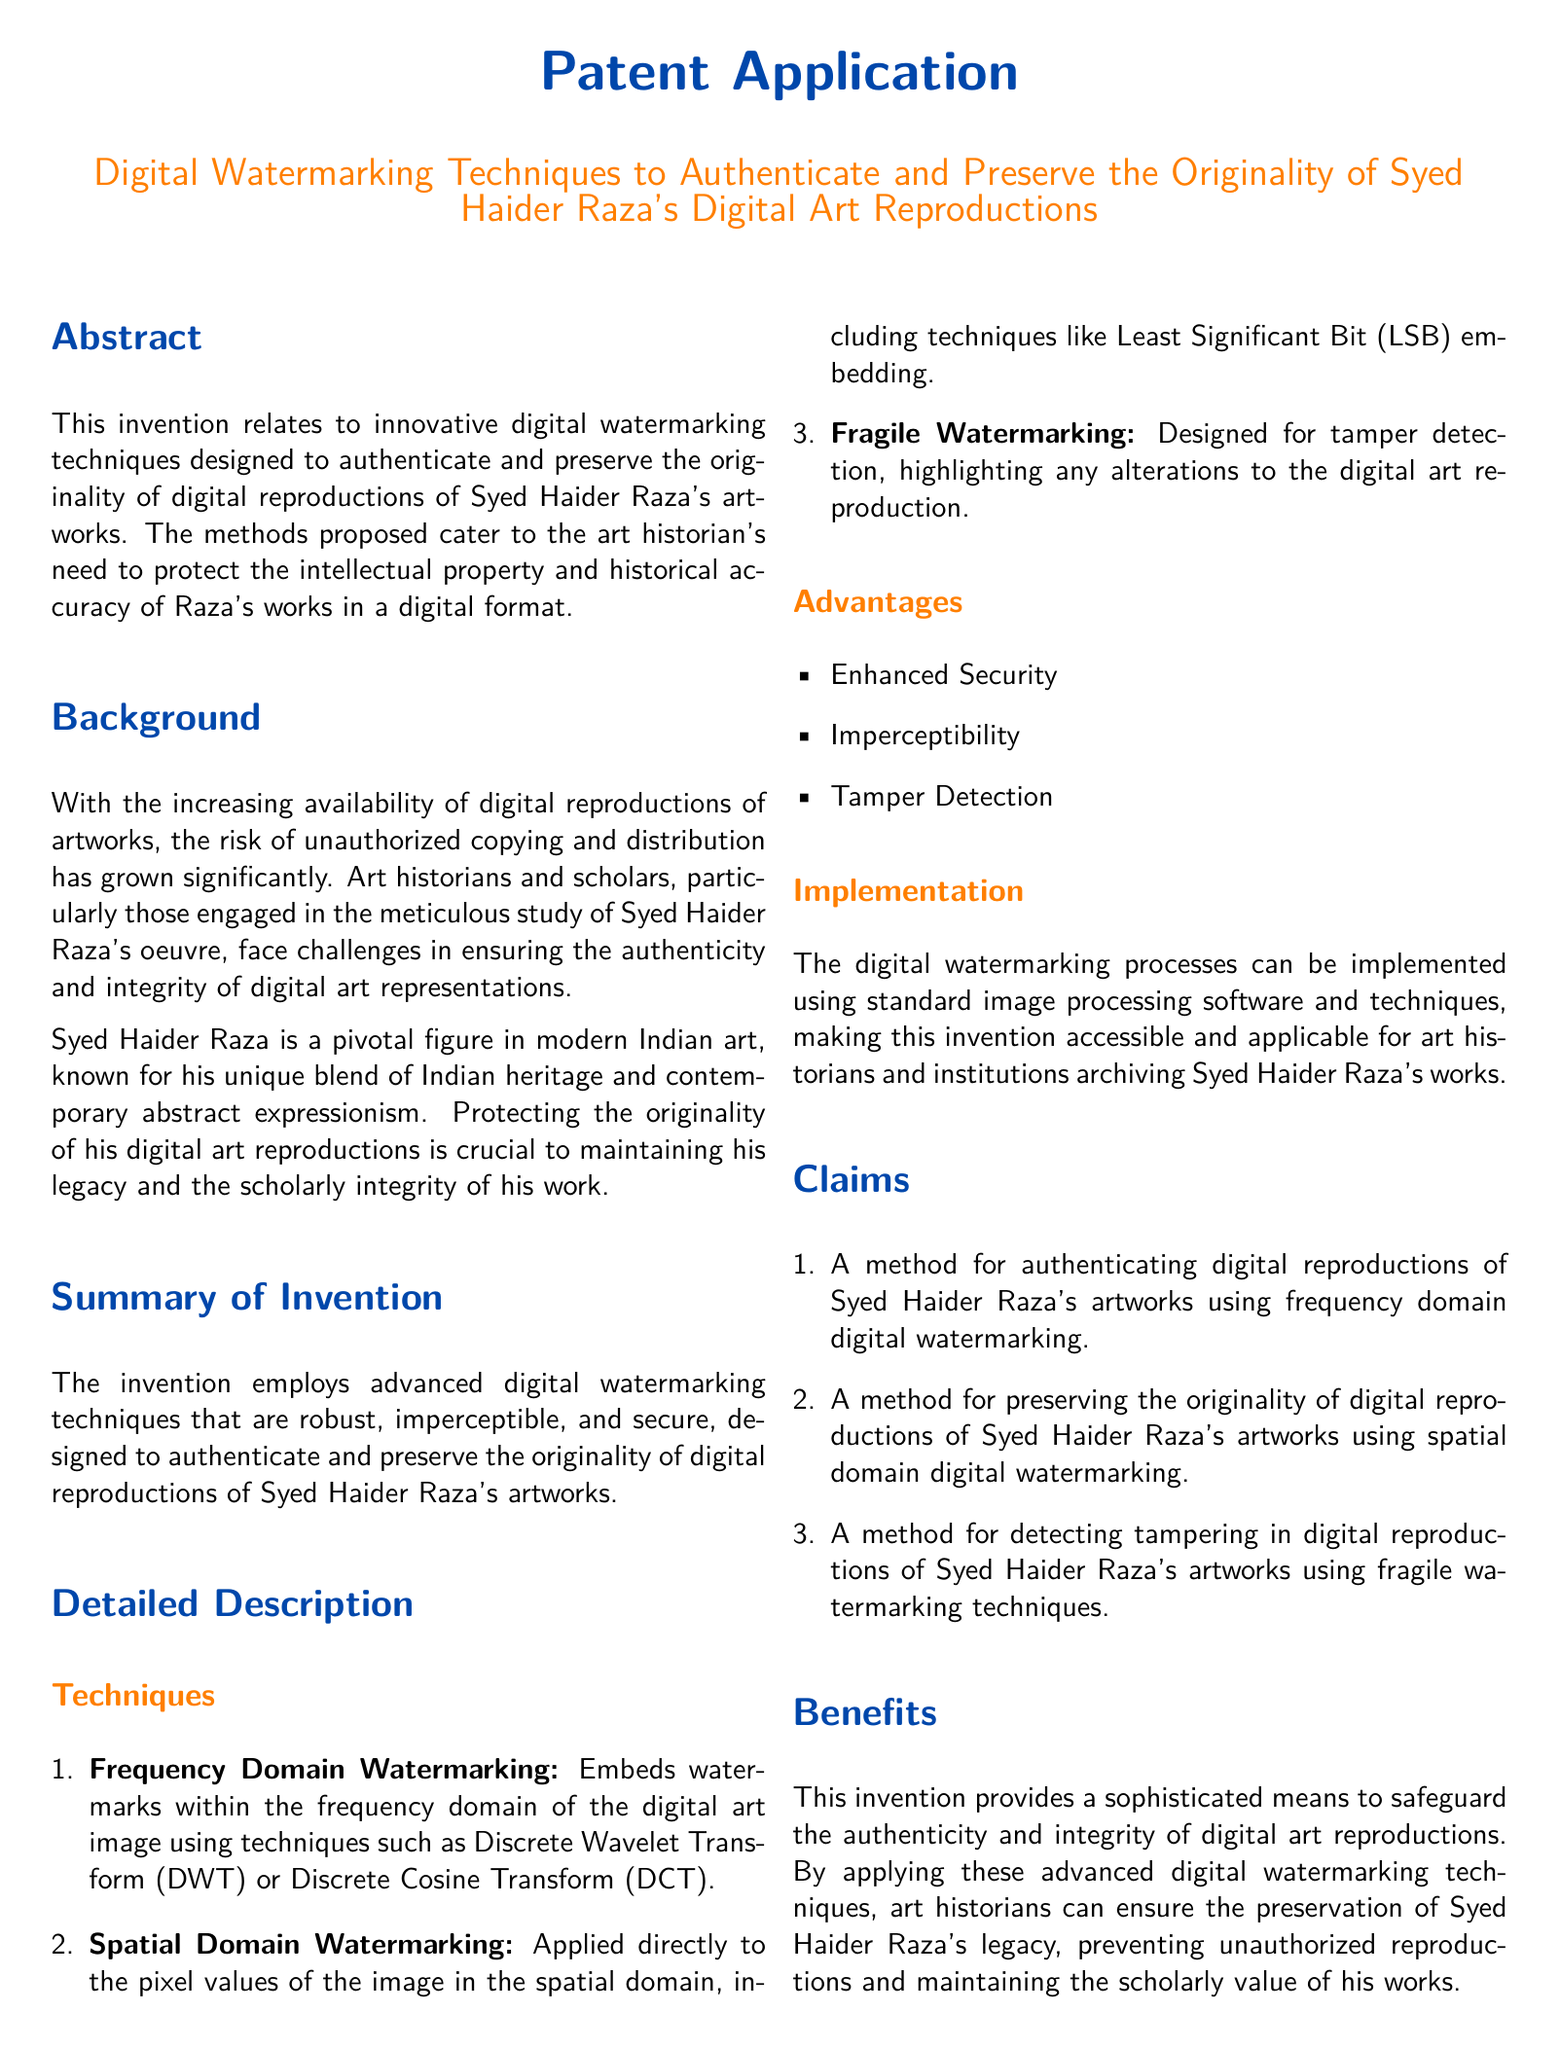What is the title of the patent application? The title of the patent application is explicitly mentioned in the document's header.
Answer: Digital Watermarking Techniques to Authenticate and Preserve the Originality of Syed Haider Raza's Digital Art Reproductions Who is the primary figure discussed in the patent application? The document highlights a significant individual in modern Indian art whose works are being protected.
Answer: Syed Haider Raza What is the first method of digital watermarking mentioned? The first method listed in the techniques section involves embedding watermarks in a specific way.
Answer: Frequency Domain Watermarking What is the advantage listed under the advantages section? The document provides a list of benefits, and "Enhanced Security" is one of them.
Answer: Enhanced Security What technique is used for tamper detection? The document describes a technique specifically employed for identifying alterations in digital reproductions.
Answer: Fragile Watermarking What is the focus area of the invention? The abstract states the purpose of the invention, which is centered around a particular field.
Answer: Digital watermarking techniques How many claims does the patent application include? The claims section enumerates the different methods proposed, revealing the total count.
Answer: Three What is the summary of the invention about? The brief synopsis encapsulates the main purpose and method of the invention.
Answer: Advanced digital watermarking techniques What is the primary purpose of the invention? As described in the background section, the main goal relates to protecting a specific aspect of art.
Answer: To authenticate and preserve the originality of digital reproductions 